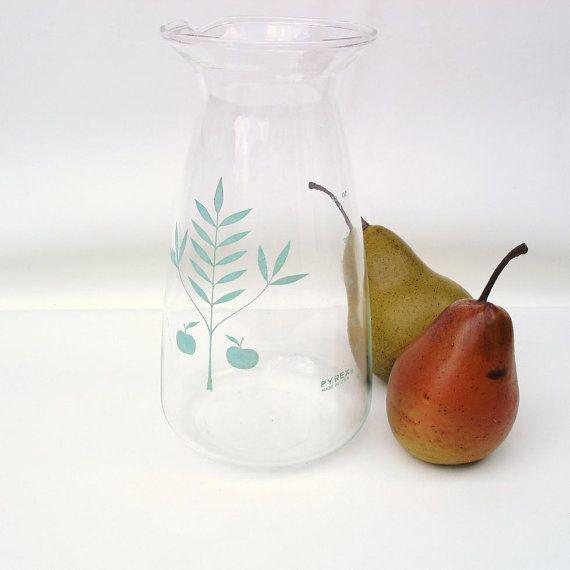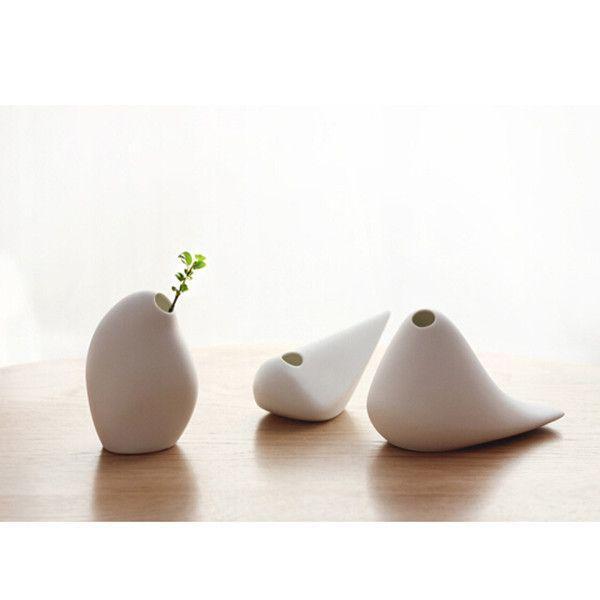The first image is the image on the left, the second image is the image on the right. Assess this claim about the two images: "In the right side image, there is a plant in only one of the vases.". Correct or not? Answer yes or no. Yes. The first image is the image on the left, the second image is the image on the right. Examine the images to the left and right. Is the description "There are 2 pieces of fruit sitting next to a vase." accurate? Answer yes or no. Yes. 